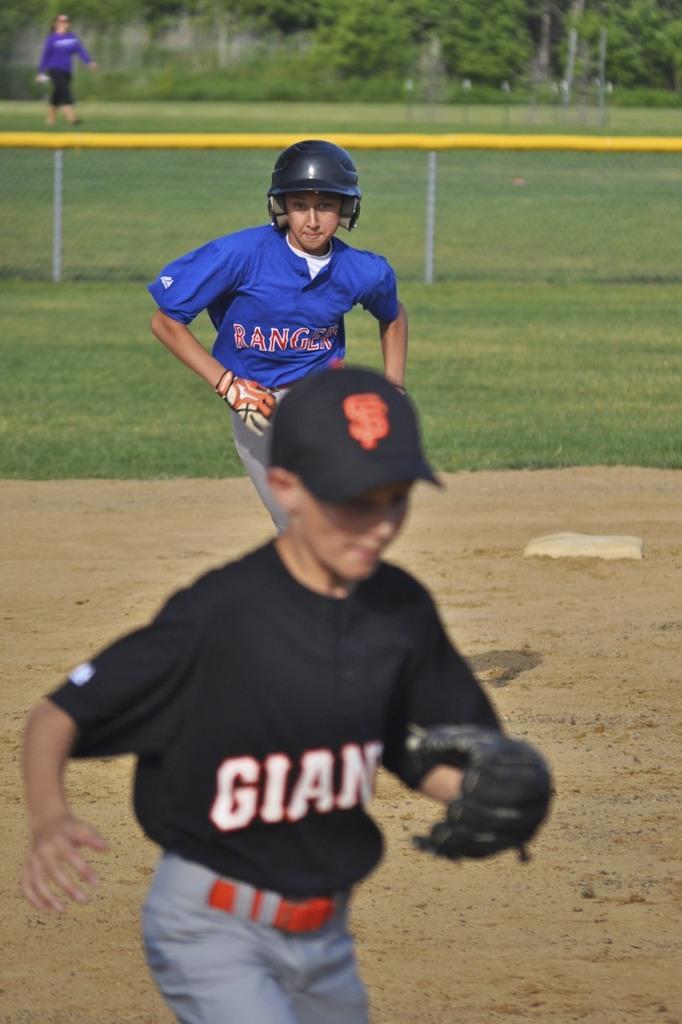Who does the kid in black play for?
Make the answer very short. Giants. 